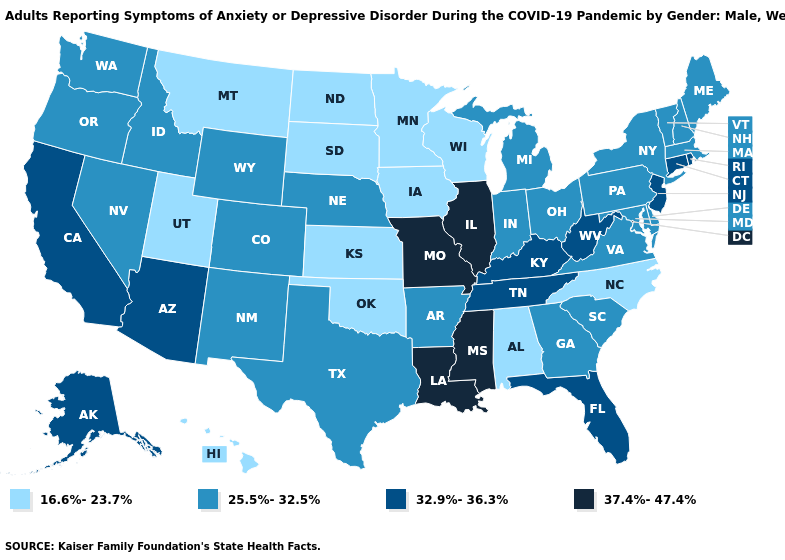Which states hav the highest value in the Northeast?
Quick response, please. Connecticut, New Jersey, Rhode Island. Does the first symbol in the legend represent the smallest category?
Write a very short answer. Yes. What is the highest value in the South ?
Answer briefly. 37.4%-47.4%. Which states have the lowest value in the USA?
Give a very brief answer. Alabama, Hawaii, Iowa, Kansas, Minnesota, Montana, North Carolina, North Dakota, Oklahoma, South Dakota, Utah, Wisconsin. Does the first symbol in the legend represent the smallest category?
Answer briefly. Yes. What is the lowest value in the South?
Write a very short answer. 16.6%-23.7%. Among the states that border North Dakota , which have the highest value?
Keep it brief. Minnesota, Montana, South Dakota. What is the lowest value in the MidWest?
Concise answer only. 16.6%-23.7%. Name the states that have a value in the range 32.9%-36.3%?
Write a very short answer. Alaska, Arizona, California, Connecticut, Florida, Kentucky, New Jersey, Rhode Island, Tennessee, West Virginia. Does Mississippi have the highest value in the USA?
Be succinct. Yes. Does Missouri have the highest value in the MidWest?
Quick response, please. Yes. Does Kentucky have the same value as Texas?
Keep it brief. No. Which states have the highest value in the USA?
Keep it brief. Illinois, Louisiana, Mississippi, Missouri. Name the states that have a value in the range 32.9%-36.3%?
Concise answer only. Alaska, Arizona, California, Connecticut, Florida, Kentucky, New Jersey, Rhode Island, Tennessee, West Virginia. Which states have the highest value in the USA?
Keep it brief. Illinois, Louisiana, Mississippi, Missouri. 